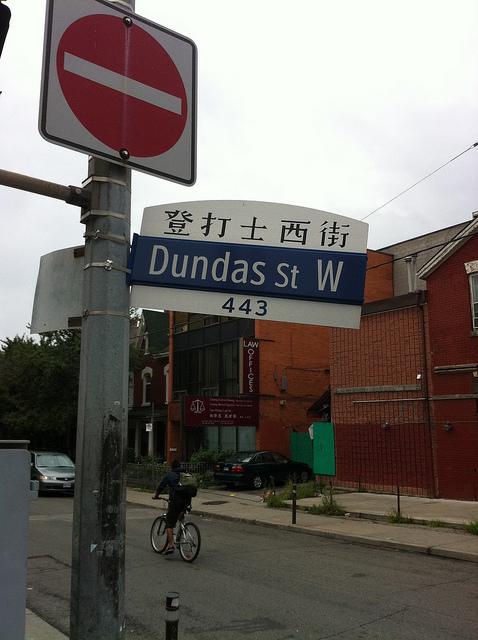Is there a bike lane?
Keep it brief. No. What is the color of the fence?
Concise answer only. Silver. How many signs are there?
Quick response, please. 2. What number is under the street name?
Write a very short answer. 443. Where is this?
Be succinct. Dundas st w. What street is this?
Write a very short answer. Dundas st w. What is the name of this street?
Be succinct. Dundas. What direction is it?
Write a very short answer. West. 